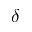<formula> <loc_0><loc_0><loc_500><loc_500>\delta</formula> 